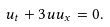<formula> <loc_0><loc_0><loc_500><loc_500>u _ { t } + 3 u u _ { x } = 0 .</formula> 